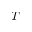<formula> <loc_0><loc_0><loc_500><loc_500>T</formula> 